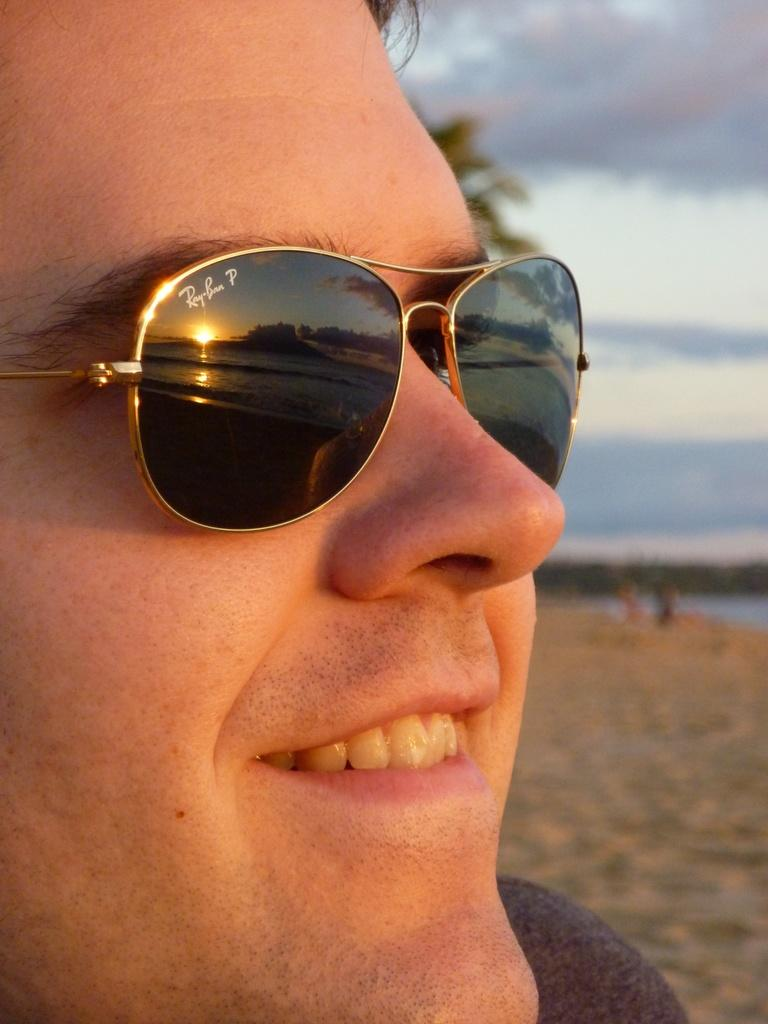What can be seen in the image? There is a person in the image. How is the person's expression? The person is smiling. What is the person wearing on their face? The person is wearing goggles. What is visible in the sky in the image? There are clouds visible in the sky in the image. What type of bee can be seen buzzing around the person's head in the image? There is no bee present in the image; the person is wearing goggles, which might suggest an activity that does not involve bees. 